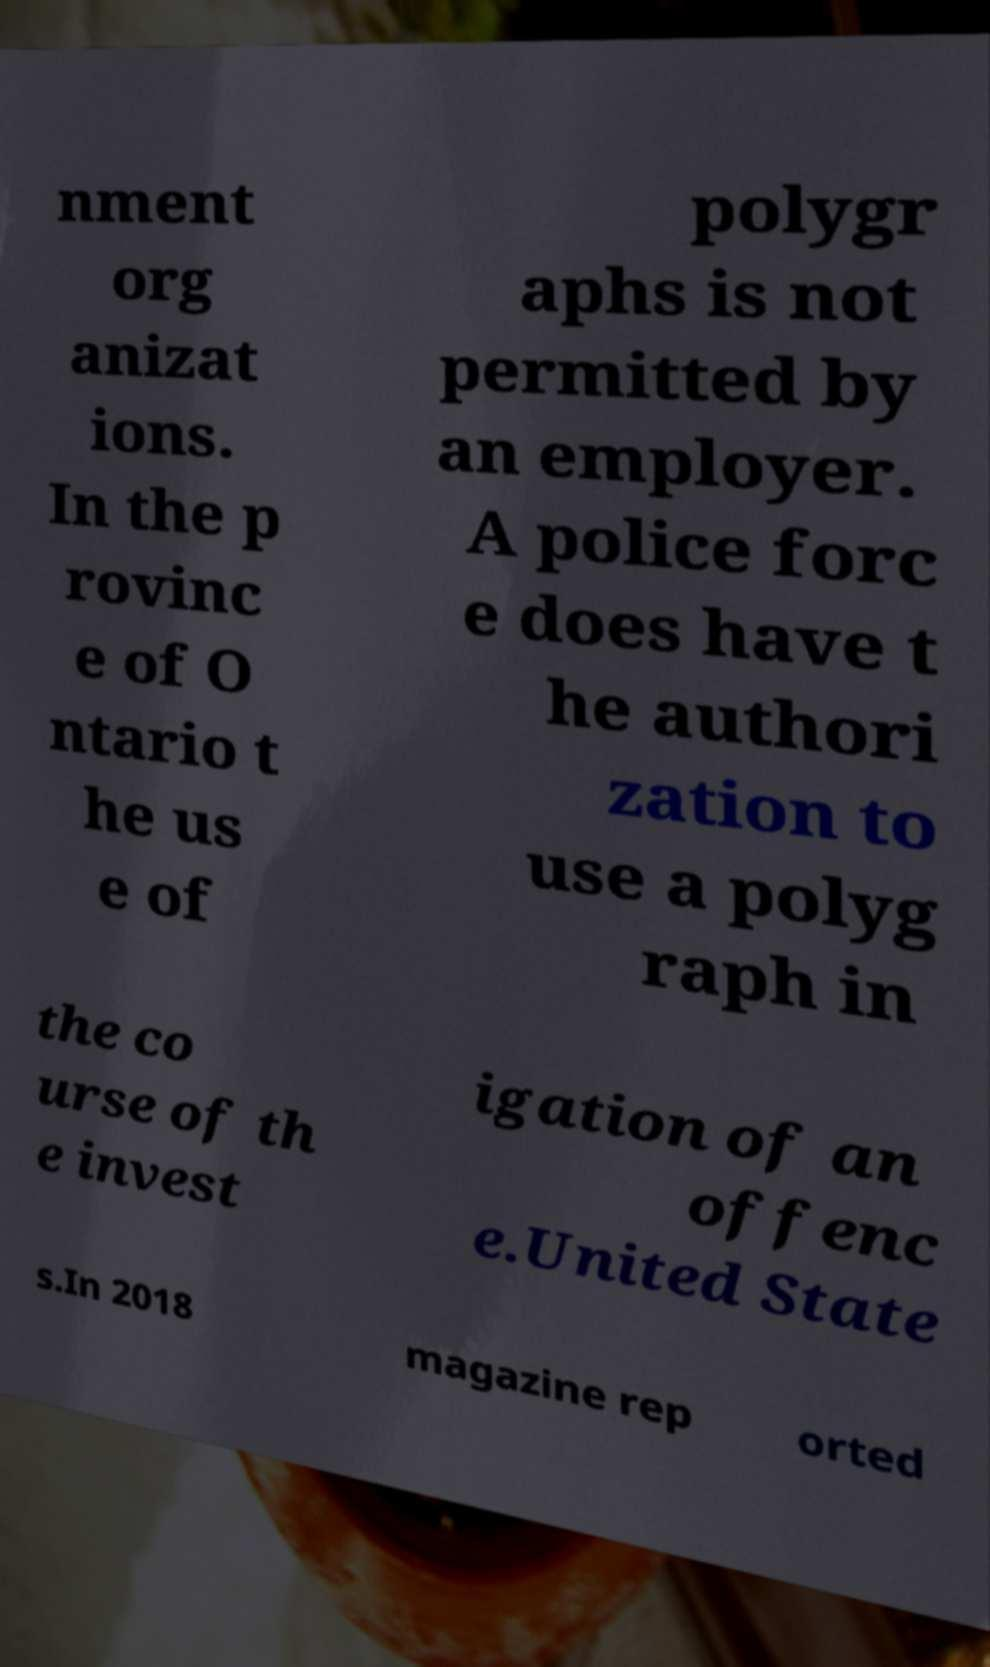What messages or text are displayed in this image? I need them in a readable, typed format. nment org anizat ions. In the p rovinc e of O ntario t he us e of polygr aphs is not permitted by an employer. A police forc e does have t he authori zation to use a polyg raph in the co urse of th e invest igation of an offenc e.United State s.In 2018 magazine rep orted 